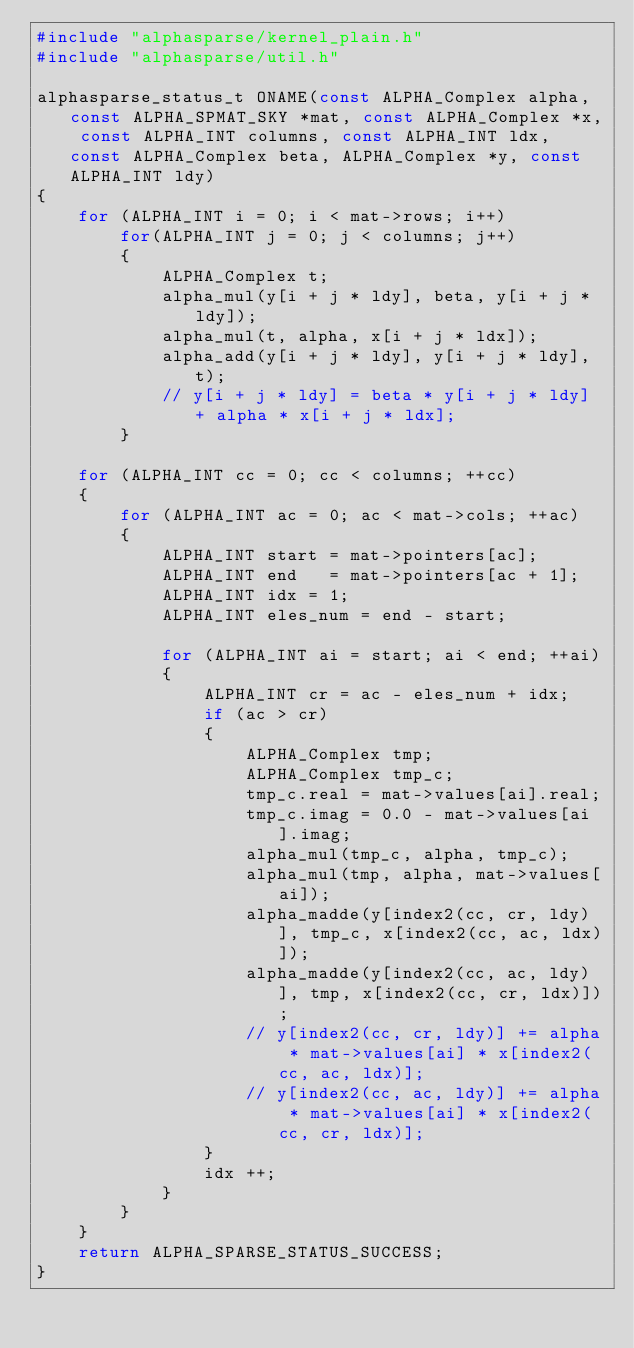Convert code to text. <code><loc_0><loc_0><loc_500><loc_500><_C_>#include "alphasparse/kernel_plain.h"
#include "alphasparse/util.h"

alphasparse_status_t ONAME(const ALPHA_Complex alpha, const ALPHA_SPMAT_SKY *mat, const ALPHA_Complex *x, const ALPHA_INT columns, const ALPHA_INT ldx, const ALPHA_Complex beta, ALPHA_Complex *y, const ALPHA_INT ldy)
{
    for (ALPHA_INT i = 0; i < mat->rows; i++)
        for(ALPHA_INT j = 0; j < columns; j++)
        {
            ALPHA_Complex t;
            alpha_mul(y[i + j * ldy], beta, y[i + j * ldy]);
            alpha_mul(t, alpha, x[i + j * ldx]);
            alpha_add(y[i + j * ldy], y[i + j * ldy], t);
            // y[i + j * ldy] = beta * y[i + j * ldy] + alpha * x[i + j * ldx];
        }            
            
    for (ALPHA_INT cc = 0; cc < columns; ++cc)
    {
        for (ALPHA_INT ac = 0; ac < mat->cols; ++ac)
        {
            ALPHA_INT start = mat->pointers[ac];
            ALPHA_INT end   = mat->pointers[ac + 1];
            ALPHA_INT idx = 1;
            ALPHA_INT eles_num = end - start;

            for (ALPHA_INT ai = start; ai < end; ++ai)
            {
                ALPHA_INT cr = ac - eles_num + idx;
                if (ac > cr)
                {
                    ALPHA_Complex tmp;
                    ALPHA_Complex tmp_c;
                    tmp_c.real = mat->values[ai].real;
                    tmp_c.imag = 0.0 - mat->values[ai].imag;
                    alpha_mul(tmp_c, alpha, tmp_c);
                    alpha_mul(tmp, alpha, mat->values[ai]);
                    alpha_madde(y[index2(cc, cr, ldy)], tmp_c, x[index2(cc, ac, ldx)]);
                    alpha_madde(y[index2(cc, ac, ldy)], tmp, x[index2(cc, cr, ldx)]);
                    // y[index2(cc, cr, ldy)] += alpha * mat->values[ai] * x[index2(cc, ac, ldx)];
                    // y[index2(cc, ac, ldy)] += alpha * mat->values[ai] * x[index2(cc, cr, ldx)];
                }
                idx ++;
            }
        }
    }
    return ALPHA_SPARSE_STATUS_SUCCESS;
}
</code> 